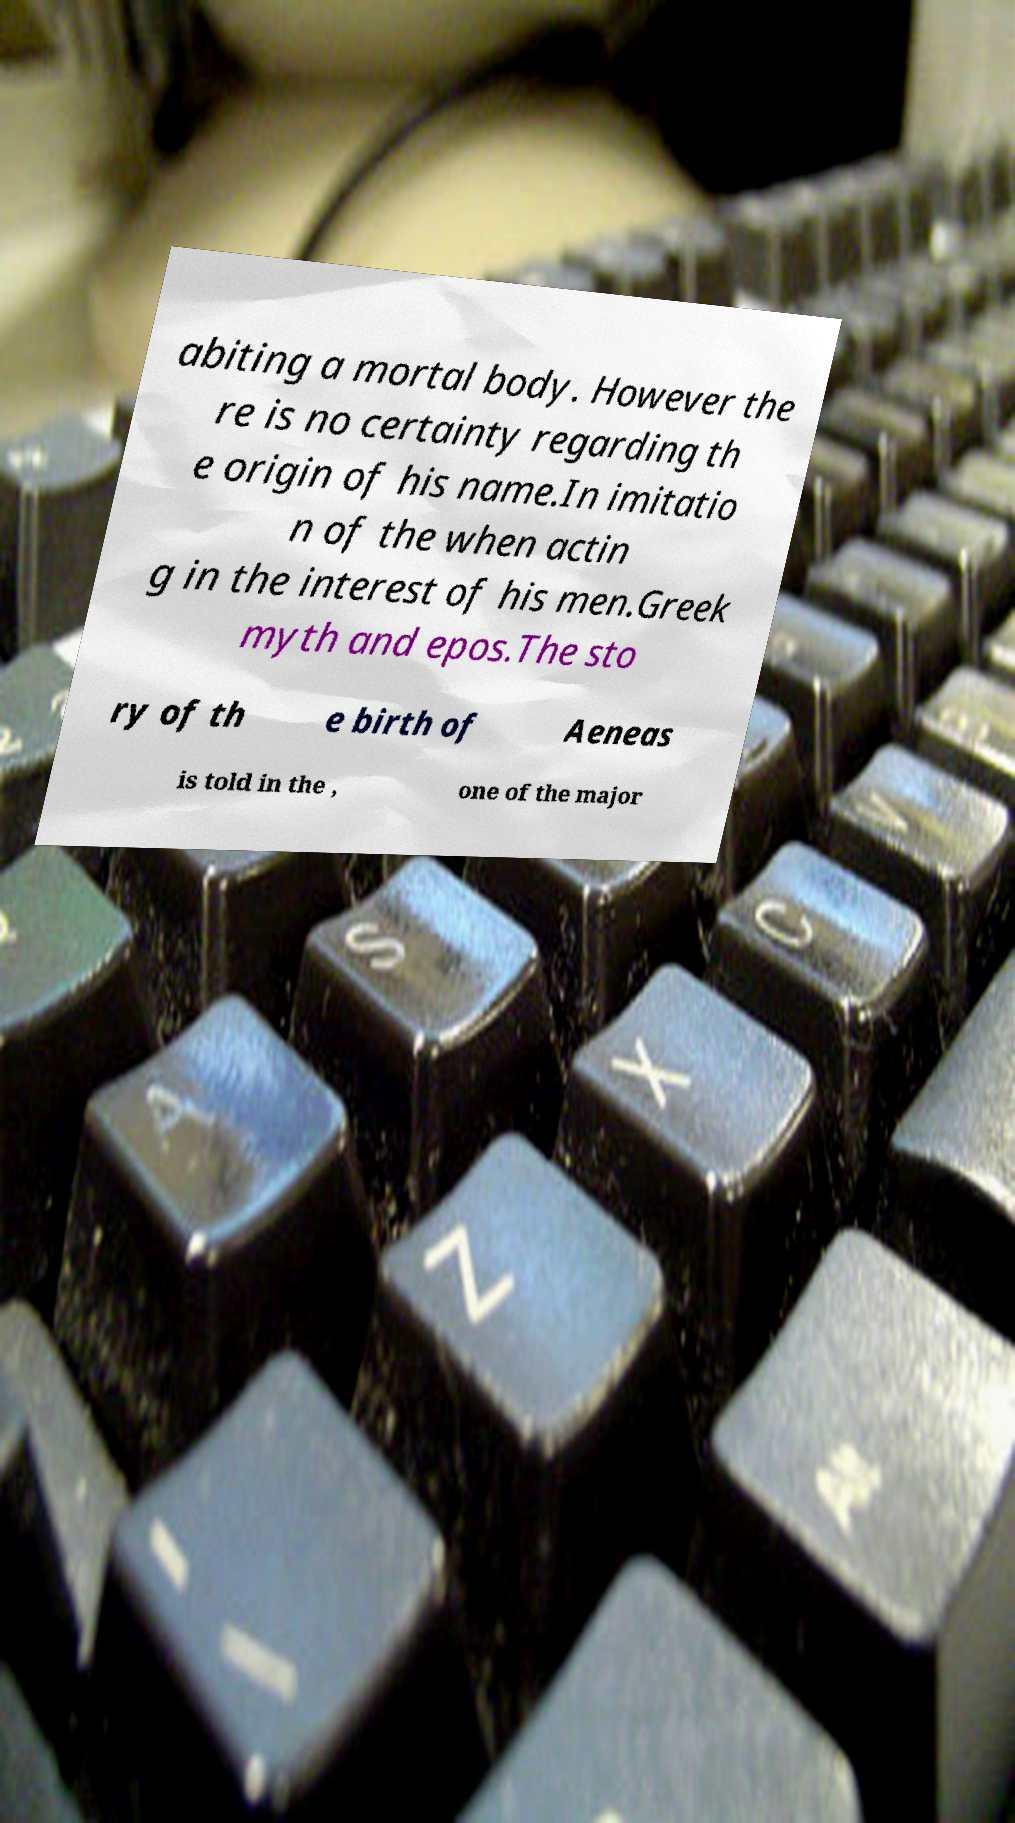I need the written content from this picture converted into text. Can you do that? abiting a mortal body. However the re is no certainty regarding th e origin of his name.In imitatio n of the when actin g in the interest of his men.Greek myth and epos.The sto ry of th e birth of Aeneas is told in the , one of the major 